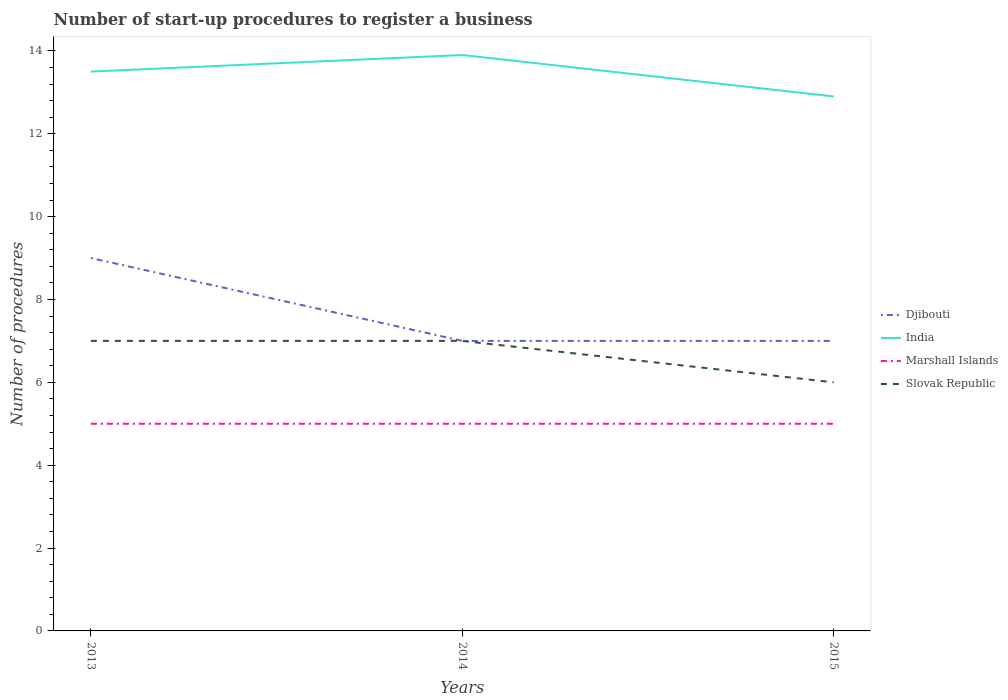How many different coloured lines are there?
Keep it short and to the point. 4. Is the number of lines equal to the number of legend labels?
Provide a short and direct response. Yes. In which year was the number of procedures required to register a business in Marshall Islands maximum?
Provide a short and direct response. 2013. What is the total number of procedures required to register a business in Djibouti in the graph?
Make the answer very short. 2. What is the difference between the highest and the lowest number of procedures required to register a business in India?
Make the answer very short. 2. Is the number of procedures required to register a business in Marshall Islands strictly greater than the number of procedures required to register a business in Slovak Republic over the years?
Give a very brief answer. Yes. How many lines are there?
Offer a terse response. 4. What is the difference between two consecutive major ticks on the Y-axis?
Give a very brief answer. 2. Are the values on the major ticks of Y-axis written in scientific E-notation?
Offer a terse response. No. Does the graph contain grids?
Offer a very short reply. No. Where does the legend appear in the graph?
Provide a short and direct response. Center right. What is the title of the graph?
Keep it short and to the point. Number of start-up procedures to register a business. What is the label or title of the Y-axis?
Offer a terse response. Number of procedures. What is the Number of procedures in India in 2013?
Provide a succinct answer. 13.5. What is the Number of procedures in Marshall Islands in 2013?
Give a very brief answer. 5. What is the Number of procedures of Djibouti in 2014?
Your answer should be compact. 7. What is the Number of procedures of Marshall Islands in 2014?
Give a very brief answer. 5. What is the Number of procedures in India in 2015?
Ensure brevity in your answer.  12.9. What is the Number of procedures in Marshall Islands in 2015?
Offer a terse response. 5. What is the Number of procedures in Slovak Republic in 2015?
Your response must be concise. 6. Across all years, what is the maximum Number of procedures of Marshall Islands?
Ensure brevity in your answer.  5. Across all years, what is the minimum Number of procedures in India?
Offer a very short reply. 12.9. What is the total Number of procedures in Djibouti in the graph?
Provide a succinct answer. 23. What is the total Number of procedures in India in the graph?
Provide a succinct answer. 40.3. What is the total Number of procedures of Marshall Islands in the graph?
Keep it short and to the point. 15. What is the difference between the Number of procedures of India in 2013 and that in 2014?
Keep it short and to the point. -0.4. What is the difference between the Number of procedures in Slovak Republic in 2013 and that in 2014?
Your answer should be very brief. 0. What is the difference between the Number of procedures in India in 2014 and that in 2015?
Ensure brevity in your answer.  1. What is the difference between the Number of procedures in Djibouti in 2013 and the Number of procedures in Marshall Islands in 2014?
Your answer should be compact. 4. What is the difference between the Number of procedures in Djibouti in 2013 and the Number of procedures in India in 2015?
Your response must be concise. -3.9. What is the difference between the Number of procedures in Djibouti in 2013 and the Number of procedures in Slovak Republic in 2015?
Provide a succinct answer. 3. What is the difference between the Number of procedures of India in 2013 and the Number of procedures of Slovak Republic in 2015?
Your answer should be very brief. 7.5. What is the difference between the Number of procedures in Marshall Islands in 2013 and the Number of procedures in Slovak Republic in 2015?
Provide a short and direct response. -1. What is the difference between the Number of procedures of Djibouti in 2014 and the Number of procedures of India in 2015?
Give a very brief answer. -5.9. What is the difference between the Number of procedures of Djibouti in 2014 and the Number of procedures of Marshall Islands in 2015?
Give a very brief answer. 2. What is the difference between the Number of procedures of Djibouti in 2014 and the Number of procedures of Slovak Republic in 2015?
Provide a succinct answer. 1. What is the difference between the Number of procedures of Marshall Islands in 2014 and the Number of procedures of Slovak Republic in 2015?
Make the answer very short. -1. What is the average Number of procedures in Djibouti per year?
Your response must be concise. 7.67. What is the average Number of procedures of India per year?
Your response must be concise. 13.43. What is the average Number of procedures in Marshall Islands per year?
Keep it short and to the point. 5. In the year 2013, what is the difference between the Number of procedures of Djibouti and Number of procedures of India?
Your answer should be very brief. -4.5. In the year 2013, what is the difference between the Number of procedures in Djibouti and Number of procedures in Marshall Islands?
Ensure brevity in your answer.  4. In the year 2013, what is the difference between the Number of procedures in Djibouti and Number of procedures in Slovak Republic?
Give a very brief answer. 2. In the year 2013, what is the difference between the Number of procedures of India and Number of procedures of Slovak Republic?
Provide a succinct answer. 6.5. In the year 2015, what is the difference between the Number of procedures of Djibouti and Number of procedures of India?
Your answer should be compact. -5.9. In the year 2015, what is the difference between the Number of procedures of Djibouti and Number of procedures of Marshall Islands?
Make the answer very short. 2. In the year 2015, what is the difference between the Number of procedures of India and Number of procedures of Slovak Republic?
Your answer should be very brief. 6.9. In the year 2015, what is the difference between the Number of procedures of Marshall Islands and Number of procedures of Slovak Republic?
Give a very brief answer. -1. What is the ratio of the Number of procedures of India in 2013 to that in 2014?
Provide a succinct answer. 0.97. What is the ratio of the Number of procedures in Marshall Islands in 2013 to that in 2014?
Keep it short and to the point. 1. What is the ratio of the Number of procedures of Slovak Republic in 2013 to that in 2014?
Give a very brief answer. 1. What is the ratio of the Number of procedures of India in 2013 to that in 2015?
Keep it short and to the point. 1.05. What is the ratio of the Number of procedures in Marshall Islands in 2013 to that in 2015?
Your response must be concise. 1. What is the ratio of the Number of procedures of Djibouti in 2014 to that in 2015?
Provide a succinct answer. 1. What is the ratio of the Number of procedures in India in 2014 to that in 2015?
Provide a succinct answer. 1.08. What is the ratio of the Number of procedures in Marshall Islands in 2014 to that in 2015?
Keep it short and to the point. 1. What is the difference between the highest and the second highest Number of procedures in India?
Give a very brief answer. 0.4. What is the difference between the highest and the second highest Number of procedures in Marshall Islands?
Your response must be concise. 0. 